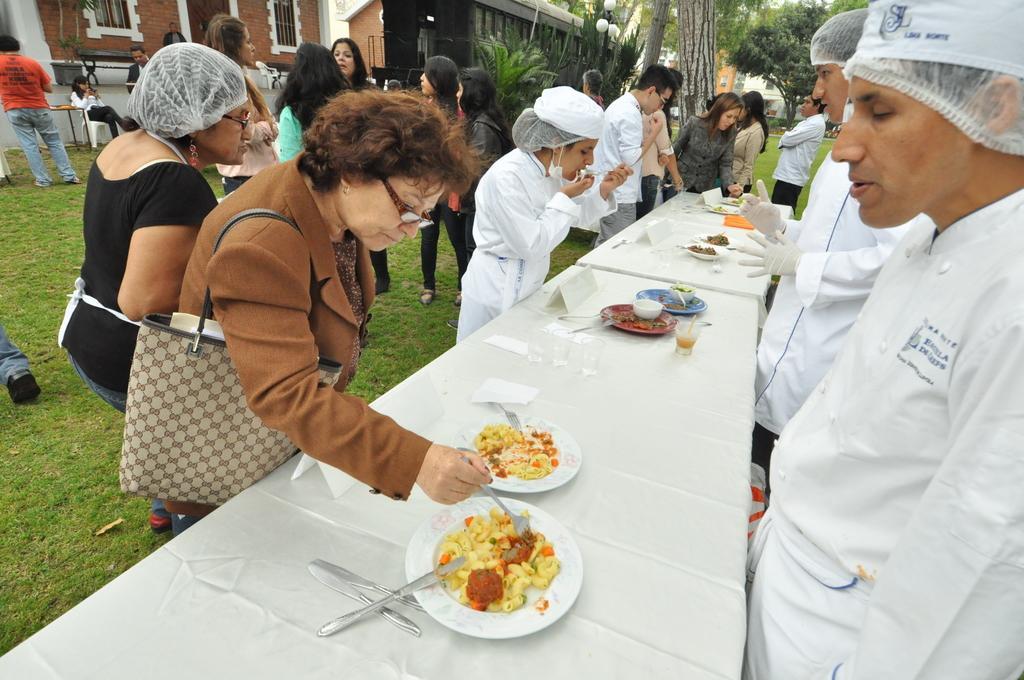Can you describe this image briefly? In the image we can see there are many people standing and one is sitting on chair. This is a table on which plate is kept, in the plate there is a food, we can even see knife, spoon. There are many trees around, building and light lamp. 